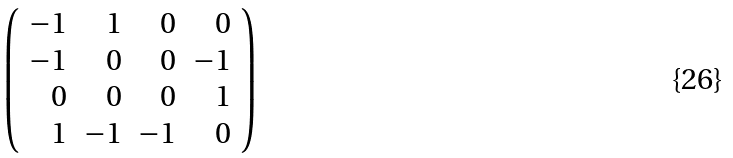Convert formula to latex. <formula><loc_0><loc_0><loc_500><loc_500>\left ( \begin{array} { r r r r } - 1 & 1 & 0 & 0 \\ - 1 & 0 & 0 & - 1 \\ 0 & 0 & 0 & 1 \\ 1 & - 1 & - 1 & 0 \end{array} \right )</formula> 